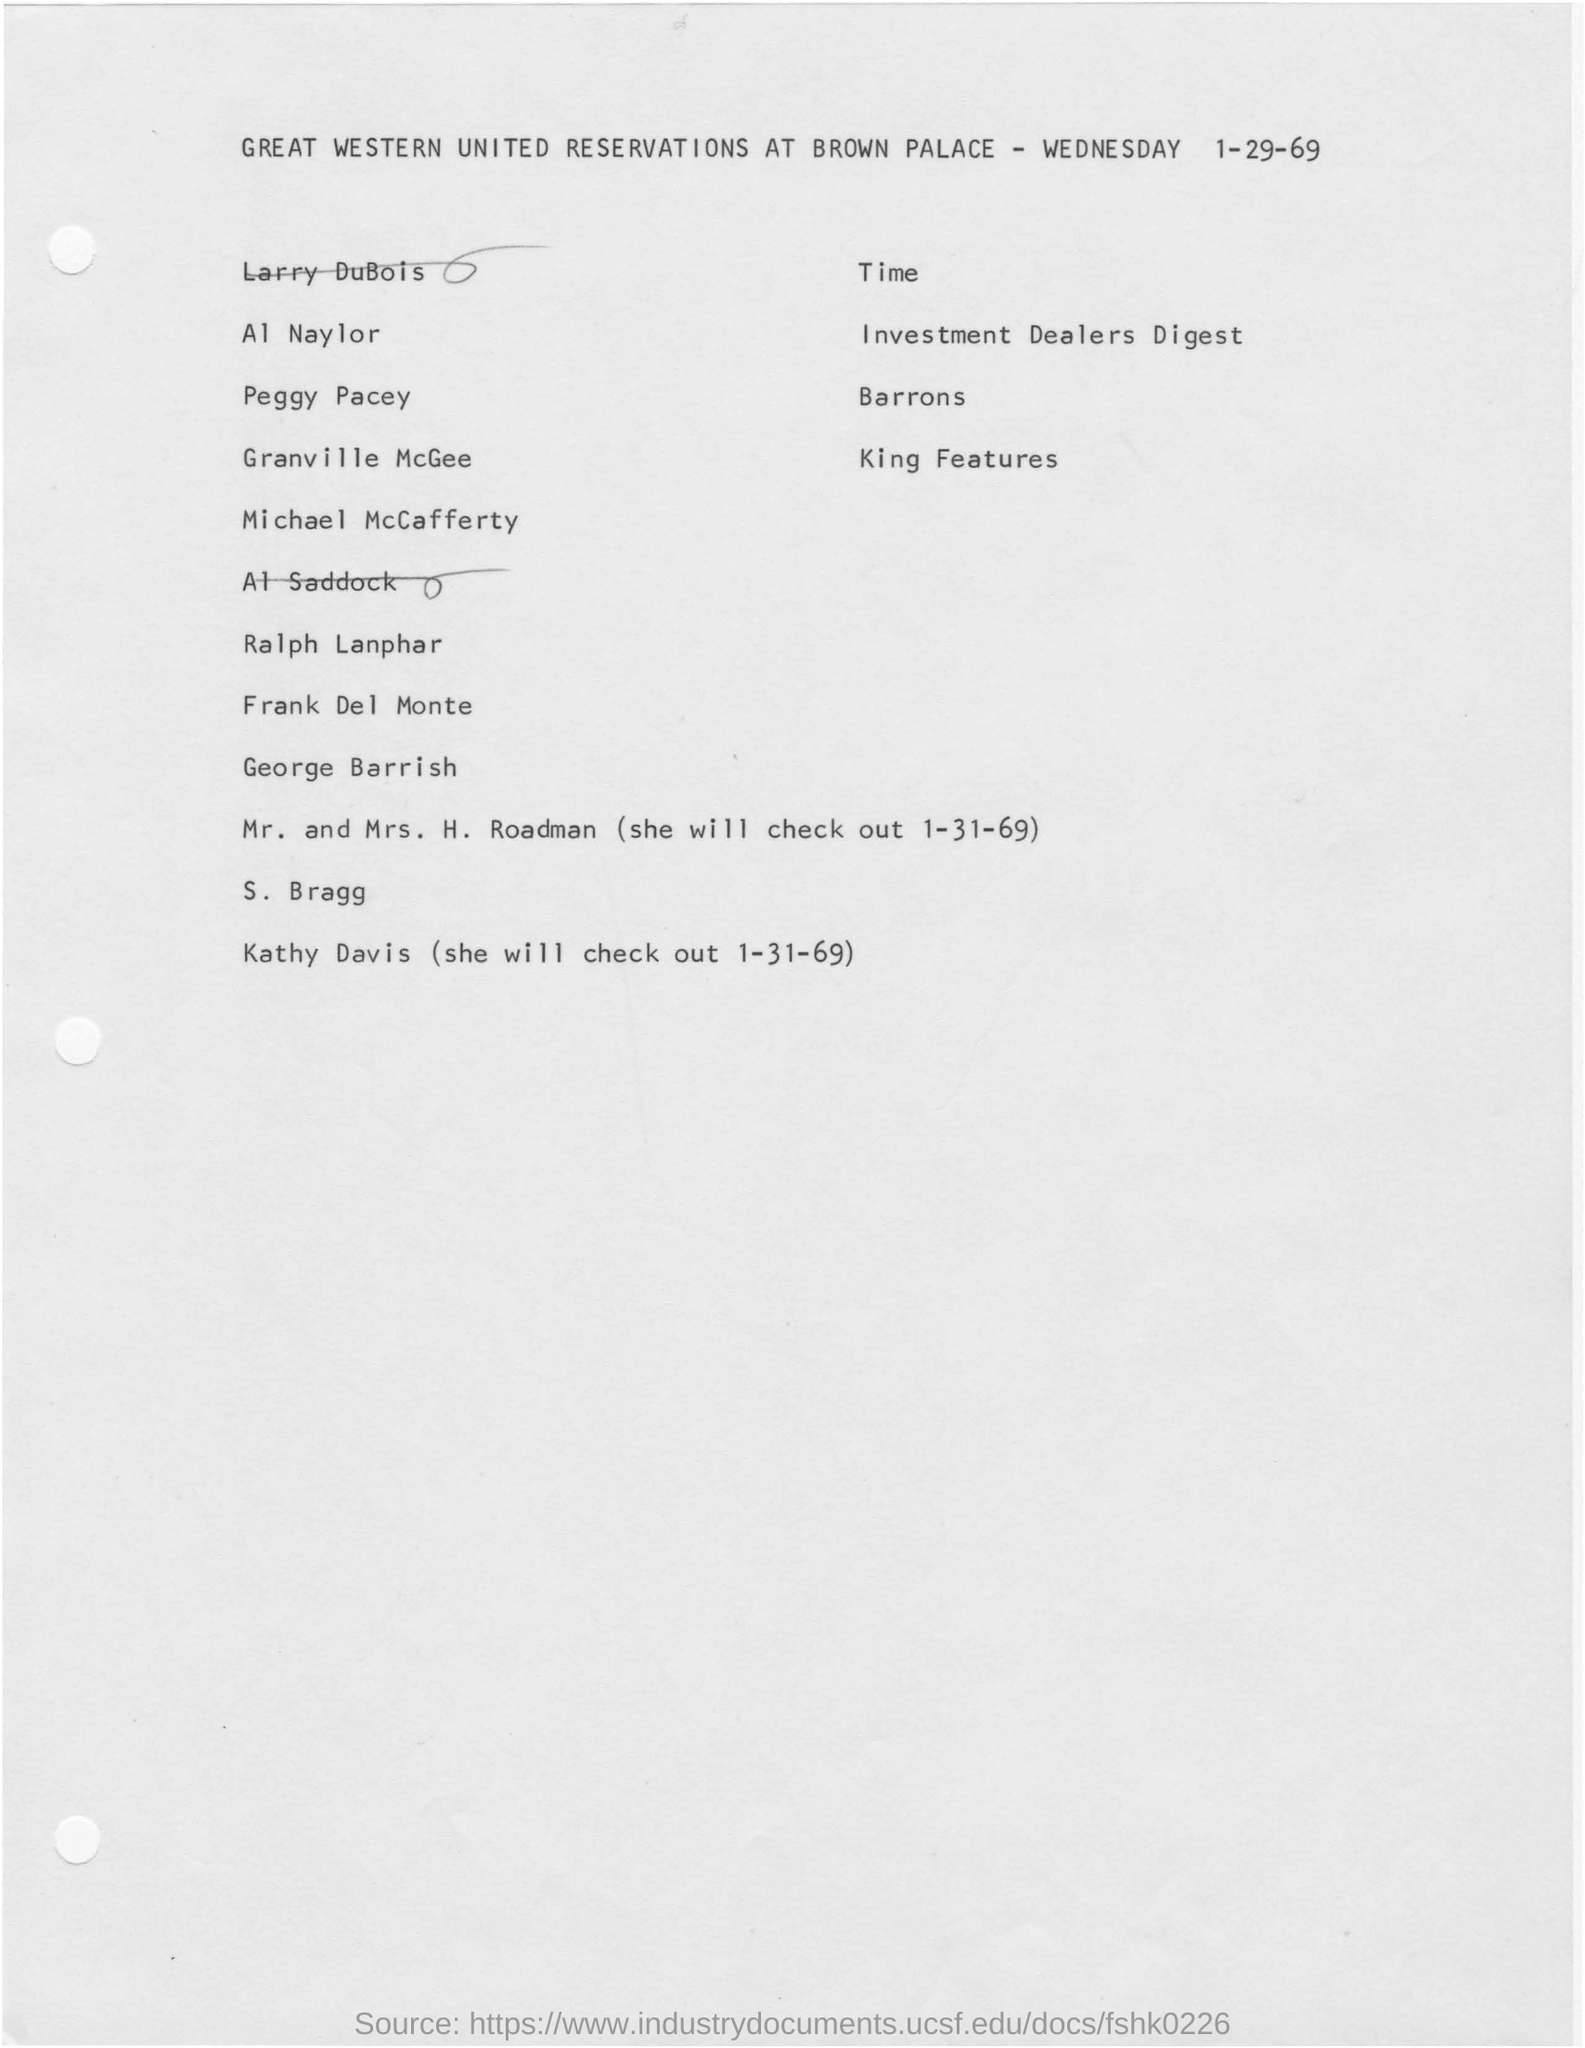Identify some key points in this picture. The document mentions Wednesday. The date mentioned at the bottom of the document is January 31, 1969. Great Western United is a company name. The date mentioned at the top of the document is January 29, 1969. 